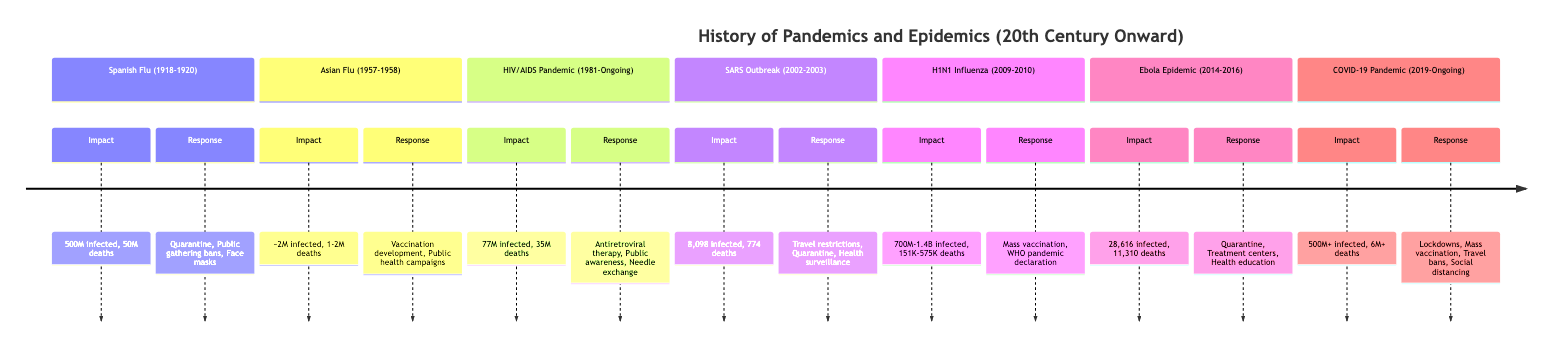What was the response strategy for the Spanish Flu? The diagram lists the response strategies for the Spanish Flu as "Quarantine," "Public gathering bans," and "Face masks."
Answer: Quarantine, Public gathering bans, Face masks How many deaths were reported during the H1N1 Influenza outbreak? The timeline indicates that H1N1 Influenza resulted in approximately "151,700 to 575,400" deaths.
Answer: 151,700 to 575,400 What is the outbreak start year for the COVID-19 Pandemic? Referring to the diagram, the outbreak start year for COVID-19 is labeled "2019."
Answer: 2019 Which outbreak had the highest number of infections listed? The timeline shows that the H1N1 Influenza outbreak had a range of "700 million to 1.4 billion" infections, which is the highest among all events listed.
Answer: 700 million to 1.4 billion What year did the Asian Flu occur? In the diagram, the Asian Flu is noted to have occurred from "1957 to 1958."
Answer: 1957 to 1958 Which pandemic has been ongoing since 1981? The diagram indicates that the HIV/AIDS Pandemic is marked as "Ongoing" since the year "1981."
Answer: HIV/AIDS Pandemic What were the economic consequences of the Ebola Epidemic? According to the timeline, the economic consequences of the Ebola Epidemic included "Severe impact on local economies, reduced workforce productivity."
Answer: Severe impact on local economies, reduced workforce productivity What response strategy was implemented during the SARS Outbreak? The timeline lists the response strategies for the SARS Outbreak as "Travel restrictions," "Quarantine," and "Public health surveillance."
Answer: Travel restrictions, Quarantine, Public health surveillance How many infected individuals were reported during the HIV/AIDS Pandemic? The diagram provides that the number of infected individuals during the HIV/AIDS Pandemic is "77 million."
Answer: 77 million 